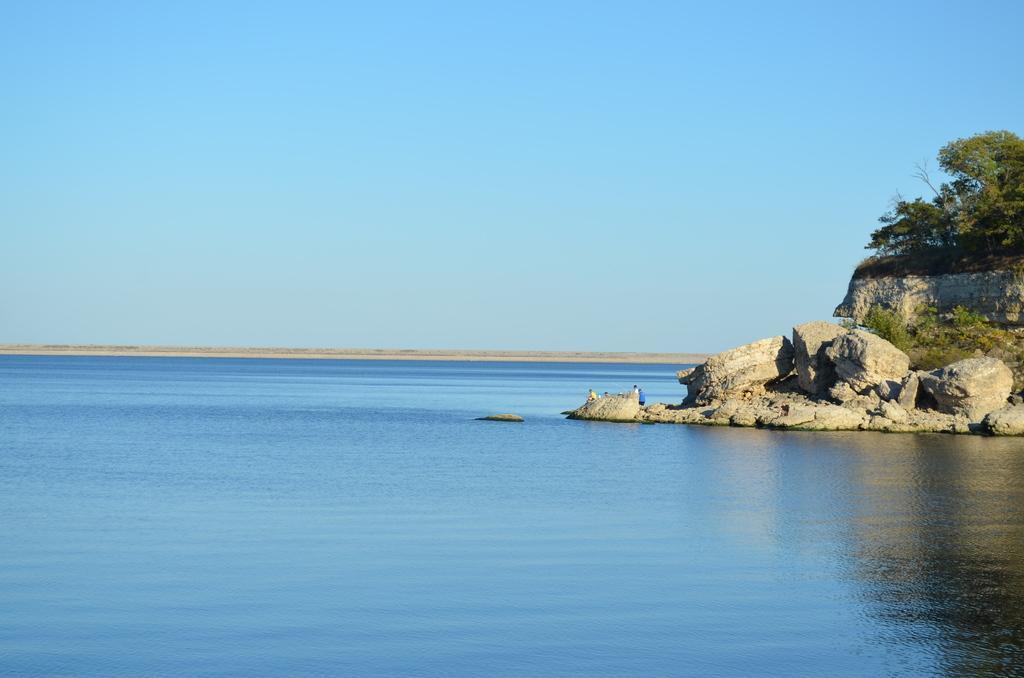Please provide a concise description of this image. This image consists of water in the middle. There are trees and rocks on the right side. There is sky at the top. 